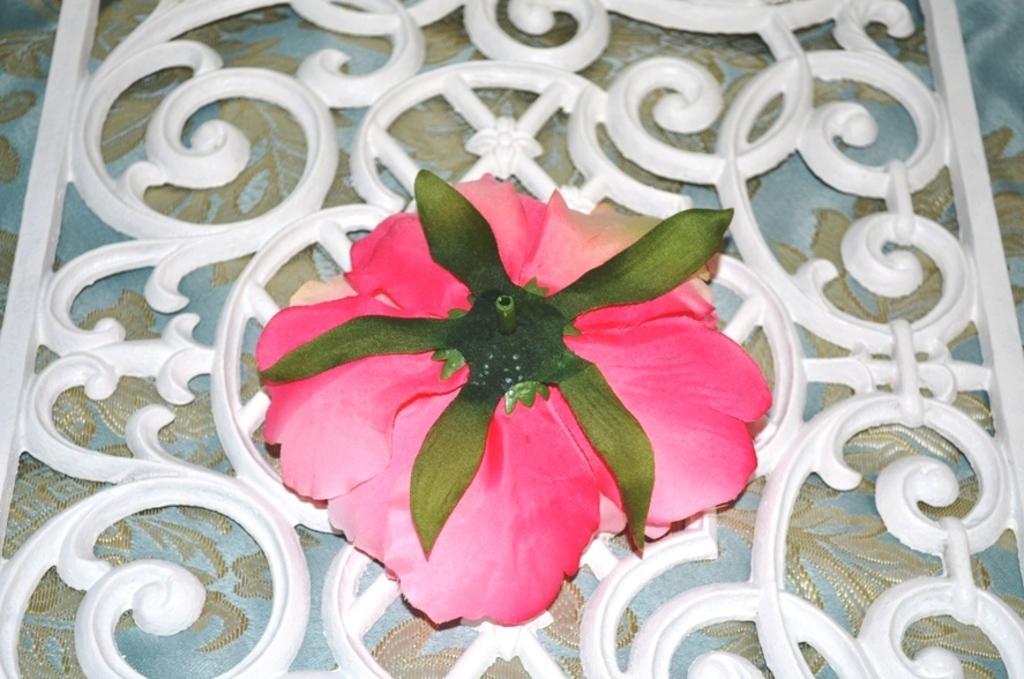Describe this image in one or two sentences. There is a pink color rose flower, arranged in reverse on the white color fencing, which is on a curtain. 